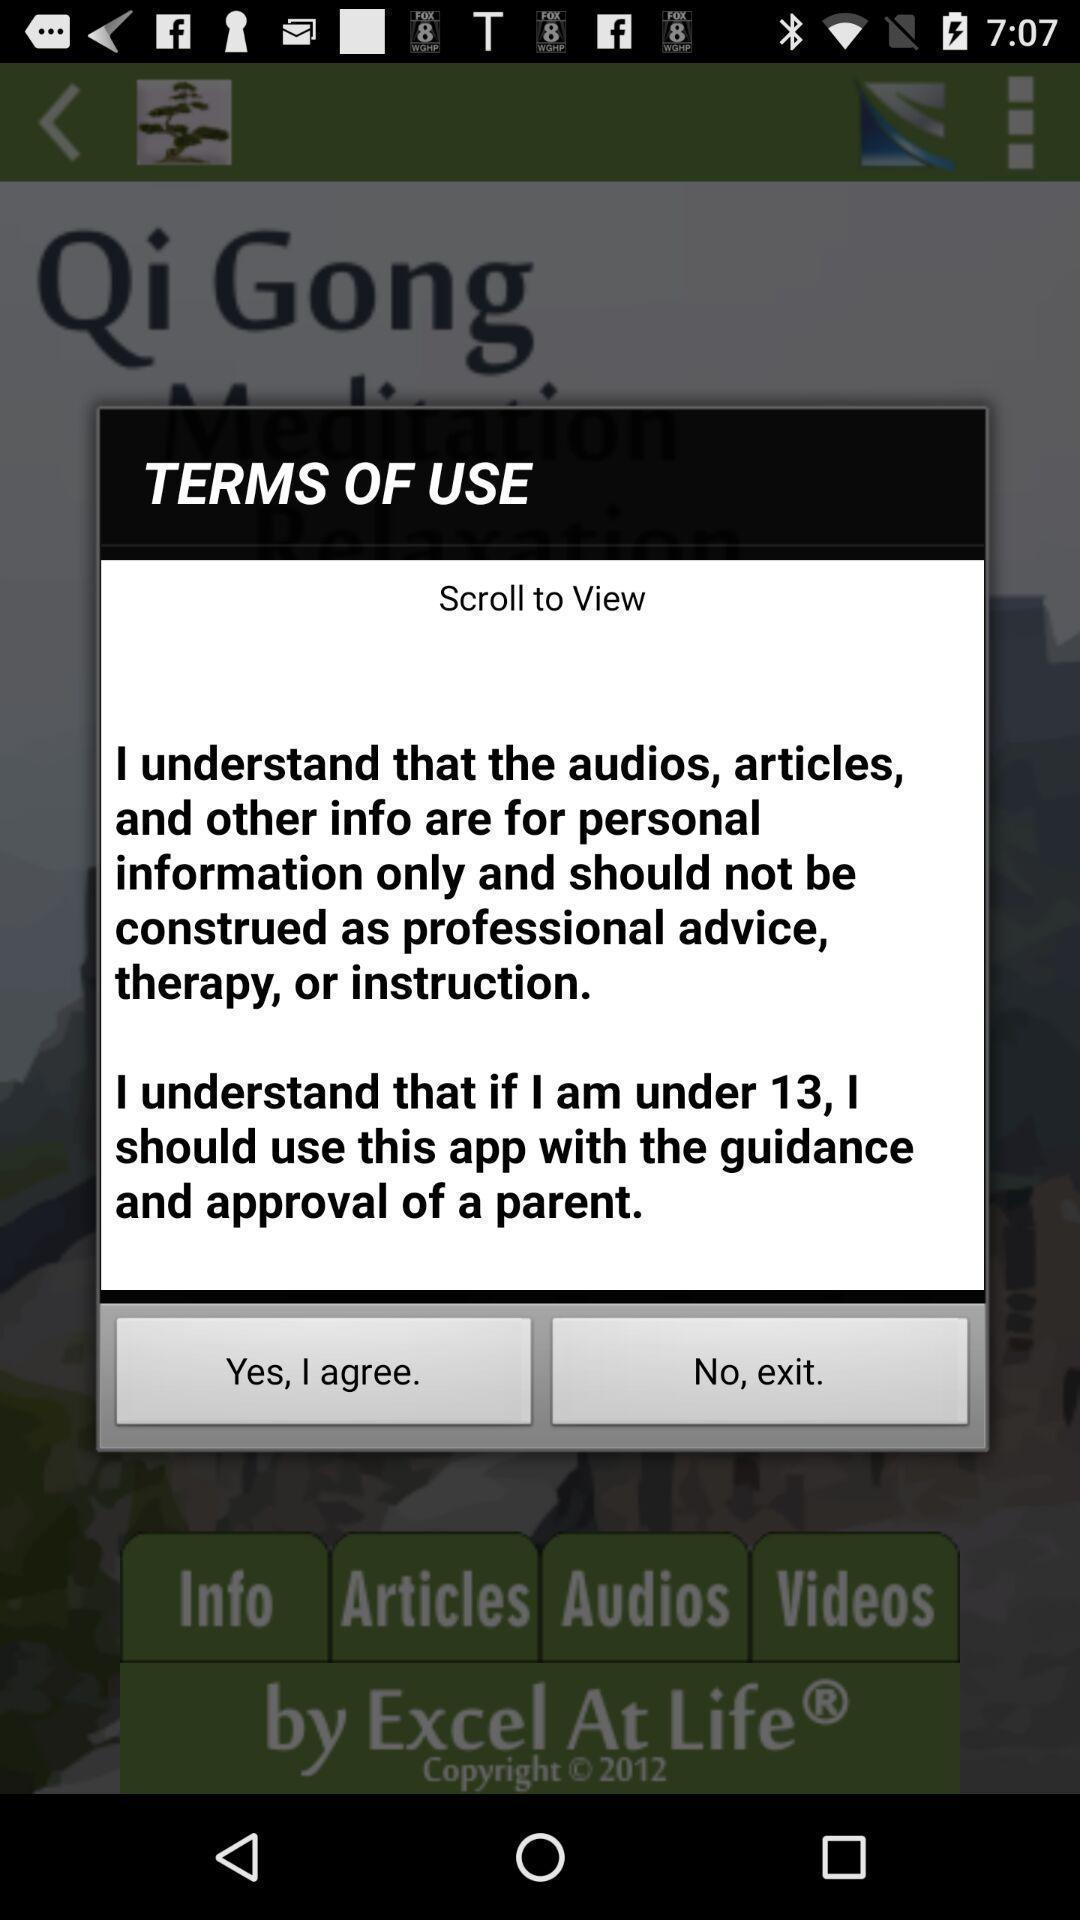Summarize the main components in this picture. Pop-up showing terms and conditions of app. 